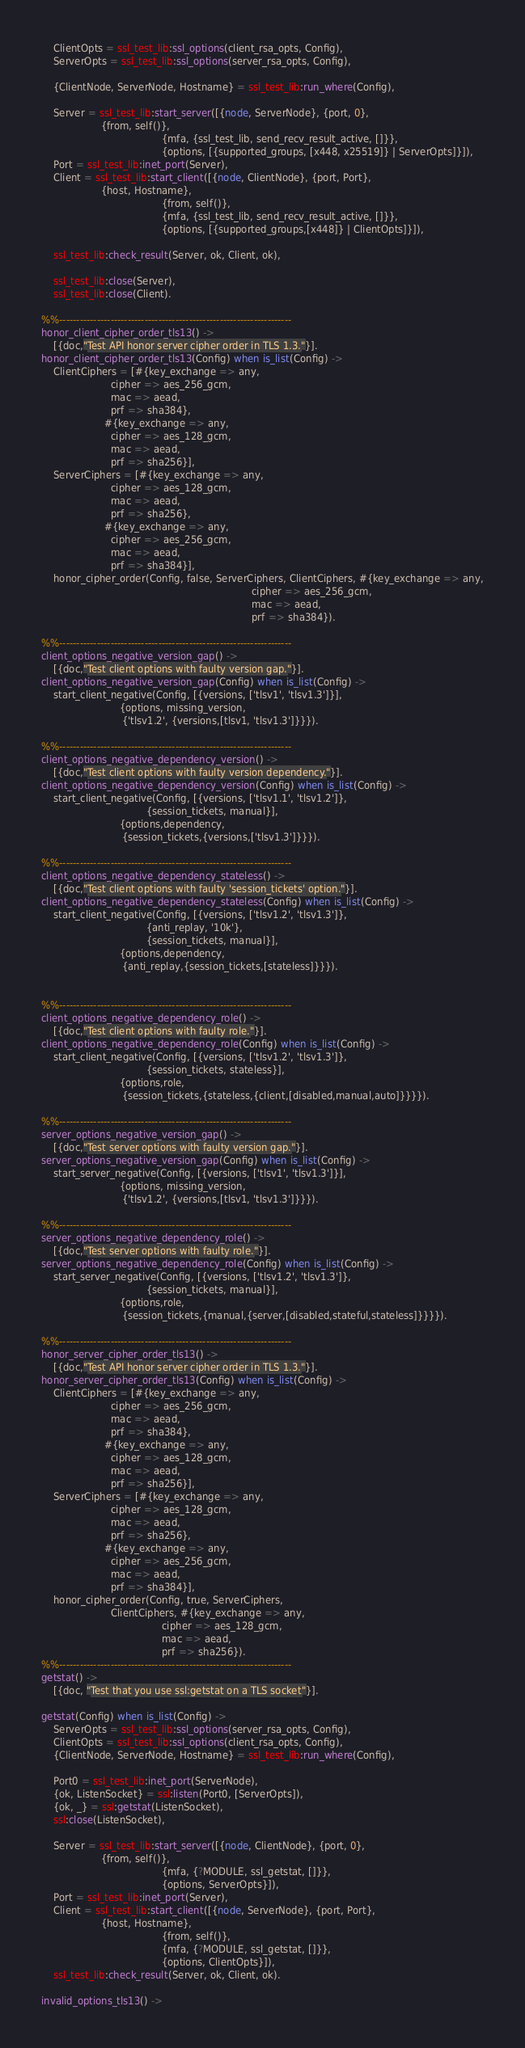<code> <loc_0><loc_0><loc_500><loc_500><_Erlang_>    ClientOpts = ssl_test_lib:ssl_options(client_rsa_opts, Config),
    ServerOpts = ssl_test_lib:ssl_options(server_rsa_opts, Config),

    {ClientNode, ServerNode, Hostname} = ssl_test_lib:run_where(Config),

    Server = ssl_test_lib:start_server([{node, ServerNode}, {port, 0},
					{from, self()},
                                        {mfa, {ssl_test_lib, send_recv_result_active, []}},
                                        {options, [{supported_groups, [x448, x25519]} | ServerOpts]}]),
    Port = ssl_test_lib:inet_port(Server),
    Client = ssl_test_lib:start_client([{node, ClientNode}, {port, Port},
					{host, Hostname},
                                        {from, self()},
                                        {mfa, {ssl_test_lib, send_recv_result_active, []}},
                                        {options, [{supported_groups,[x448]} | ClientOpts]}]),

    ssl_test_lib:check_result(Server, ok, Client, ok),

    ssl_test_lib:close(Server),
    ssl_test_lib:close(Client).

%%--------------------------------------------------------------------
honor_client_cipher_order_tls13() ->
    [{doc,"Test API honor server cipher order in TLS 1.3."}].
honor_client_cipher_order_tls13(Config) when is_list(Config) ->
    ClientCiphers = [#{key_exchange => any,
                       cipher => aes_256_gcm,
                       mac => aead,
                       prf => sha384},
                     #{key_exchange => any,
                       cipher => aes_128_gcm,
                       mac => aead,
                       prf => sha256}],
    ServerCiphers = [#{key_exchange => any,
                       cipher => aes_128_gcm,
                       mac => aead,
                       prf => sha256},
                     #{key_exchange => any,
                       cipher => aes_256_gcm,
                       mac => aead,
                       prf => sha384}],
    honor_cipher_order(Config, false, ServerCiphers, ClientCiphers, #{key_exchange => any,
                                                                      cipher => aes_256_gcm,
                                                                      mac => aead,
                                                                      prf => sha384}).

%%--------------------------------------------------------------------
client_options_negative_version_gap() ->
    [{doc,"Test client options with faulty version gap."}].
client_options_negative_version_gap(Config) when is_list(Config) ->
    start_client_negative(Config, [{versions, ['tlsv1', 'tlsv1.3']}],
                          {options, missing_version, 
                           {'tlsv1.2', {versions,[tlsv1, 'tlsv1.3']}}}).

%%--------------------------------------------------------------------
client_options_negative_dependency_version() ->
    [{doc,"Test client options with faulty version dependency."}].
client_options_negative_dependency_version(Config) when is_list(Config) ->
    start_client_negative(Config, [{versions, ['tlsv1.1', 'tlsv1.2']},
                                   {session_tickets, manual}],
                          {options,dependency,
                           {session_tickets,{versions,['tlsv1.3']}}}).

%%--------------------------------------------------------------------
client_options_negative_dependency_stateless() ->
    [{doc,"Test client options with faulty 'session_tickets' option."}].
client_options_negative_dependency_stateless(Config) when is_list(Config) ->
    start_client_negative(Config, [{versions, ['tlsv1.2', 'tlsv1.3']},
                                   {anti_replay, '10k'},
                                   {session_tickets, manual}],
                          {options,dependency,
                           {anti_replay,{session_tickets,[stateless]}}}).


%%--------------------------------------------------------------------
client_options_negative_dependency_role() ->
    [{doc,"Test client options with faulty role."}].
client_options_negative_dependency_role(Config) when is_list(Config) ->
    start_client_negative(Config, [{versions, ['tlsv1.2', 'tlsv1.3']},
                                   {session_tickets, stateless}],
                          {options,role,
                           {session_tickets,{stateless,{client,[disabled,manual,auto]}}}}).

%%--------------------------------------------------------------------
server_options_negative_version_gap() ->
    [{doc,"Test server options with faulty version gap."}].
server_options_negative_version_gap(Config) when is_list(Config) ->
    start_server_negative(Config, [{versions, ['tlsv1', 'tlsv1.3']}],
                          {options, missing_version,
                           {'tlsv1.2', {versions,[tlsv1, 'tlsv1.3']}}}).

%%--------------------------------------------------------------------
server_options_negative_dependency_role() ->
    [{doc,"Test server options with faulty role."}].
server_options_negative_dependency_role(Config) when is_list(Config) ->
    start_server_negative(Config, [{versions, ['tlsv1.2', 'tlsv1.3']},
                                   {session_tickets, manual}],
                          {options,role,
                           {session_tickets,{manual,{server,[disabled,stateful,stateless]}}}}).

%%--------------------------------------------------------------------
honor_server_cipher_order_tls13() ->
    [{doc,"Test API honor server cipher order in TLS 1.3."}].
honor_server_cipher_order_tls13(Config) when is_list(Config) ->
    ClientCiphers = [#{key_exchange => any,
                       cipher => aes_256_gcm,
                       mac => aead,
                       prf => sha384},
                     #{key_exchange => any,
                       cipher => aes_128_gcm,
                       mac => aead,
                       prf => sha256}],
    ServerCiphers = [#{key_exchange => any,
                       cipher => aes_128_gcm,
                       mac => aead,
                       prf => sha256},
                     #{key_exchange => any,
                       cipher => aes_256_gcm,
                       mac => aead,
                       prf => sha384}],
    honor_cipher_order(Config, true, ServerCiphers,
                       ClientCiphers, #{key_exchange => any,
                                        cipher => aes_128_gcm,
                                        mac => aead,
                                        prf => sha256}).
%%--------------------------------------------------------------------
getstat() ->
    [{doc, "Test that you use ssl:getstat on a TLS socket"}].

getstat(Config) when is_list(Config) ->    
    ServerOpts = ssl_test_lib:ssl_options(server_rsa_opts, Config),
    ClientOpts = ssl_test_lib:ssl_options(client_rsa_opts, Config),
    {ClientNode, ServerNode, Hostname} = ssl_test_lib:run_where(Config),
    
    Port0 = ssl_test_lib:inet_port(ServerNode),
    {ok, ListenSocket} = ssl:listen(Port0, [ServerOpts]),
    {ok, _} = ssl:getstat(ListenSocket),
    ssl:close(ListenSocket),

    Server = ssl_test_lib:start_server([{node, ClientNode}, {port, 0},
					{from, self()},
                                        {mfa, {?MODULE, ssl_getstat, []}},
                                        {options, ServerOpts}]),
    Port = ssl_test_lib:inet_port(Server),
    Client = ssl_test_lib:start_client([{node, ServerNode}, {port, Port},
					{host, Hostname},
                                        {from, self()},
                                        {mfa, {?MODULE, ssl_getstat, []}},
                                        {options, ClientOpts}]),
    ssl_test_lib:check_result(Server, ok, Client, ok).

invalid_options_tls13() -></code> 